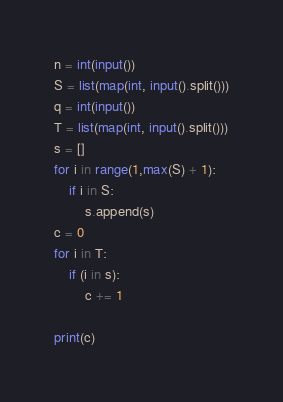<code> <loc_0><loc_0><loc_500><loc_500><_Python_>n = int(input())
S = list(map(int, input().split()))
q = int(input())
T = list(map(int, input().split()))
s = []
for i in range(1,max(S) + 1):
    if i in S:
        s.append(s)
c = 0
for i in T:
    if (i in s):
        c += 1
    
print(c)
</code> 